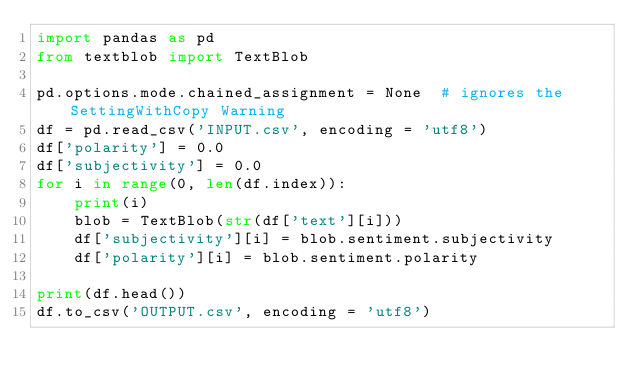Convert code to text. <code><loc_0><loc_0><loc_500><loc_500><_Python_>import pandas as pd
from textblob import TextBlob

pd.options.mode.chained_assignment = None  # ignores the SettingWithCopy Warning
df = pd.read_csv('INPUT.csv', encoding = 'utf8')
df['polarity'] = 0.0
df['subjectivity'] = 0.0
for i in range(0, len(df.index)):
    print(i)
    blob = TextBlob(str(df['text'][i]))
    df['subjectivity'][i] = blob.sentiment.subjectivity
    df['polarity'][i] = blob.sentiment.polarity

print(df.head())
df.to_csv('OUTPUT.csv', encoding = 'utf8')
</code> 